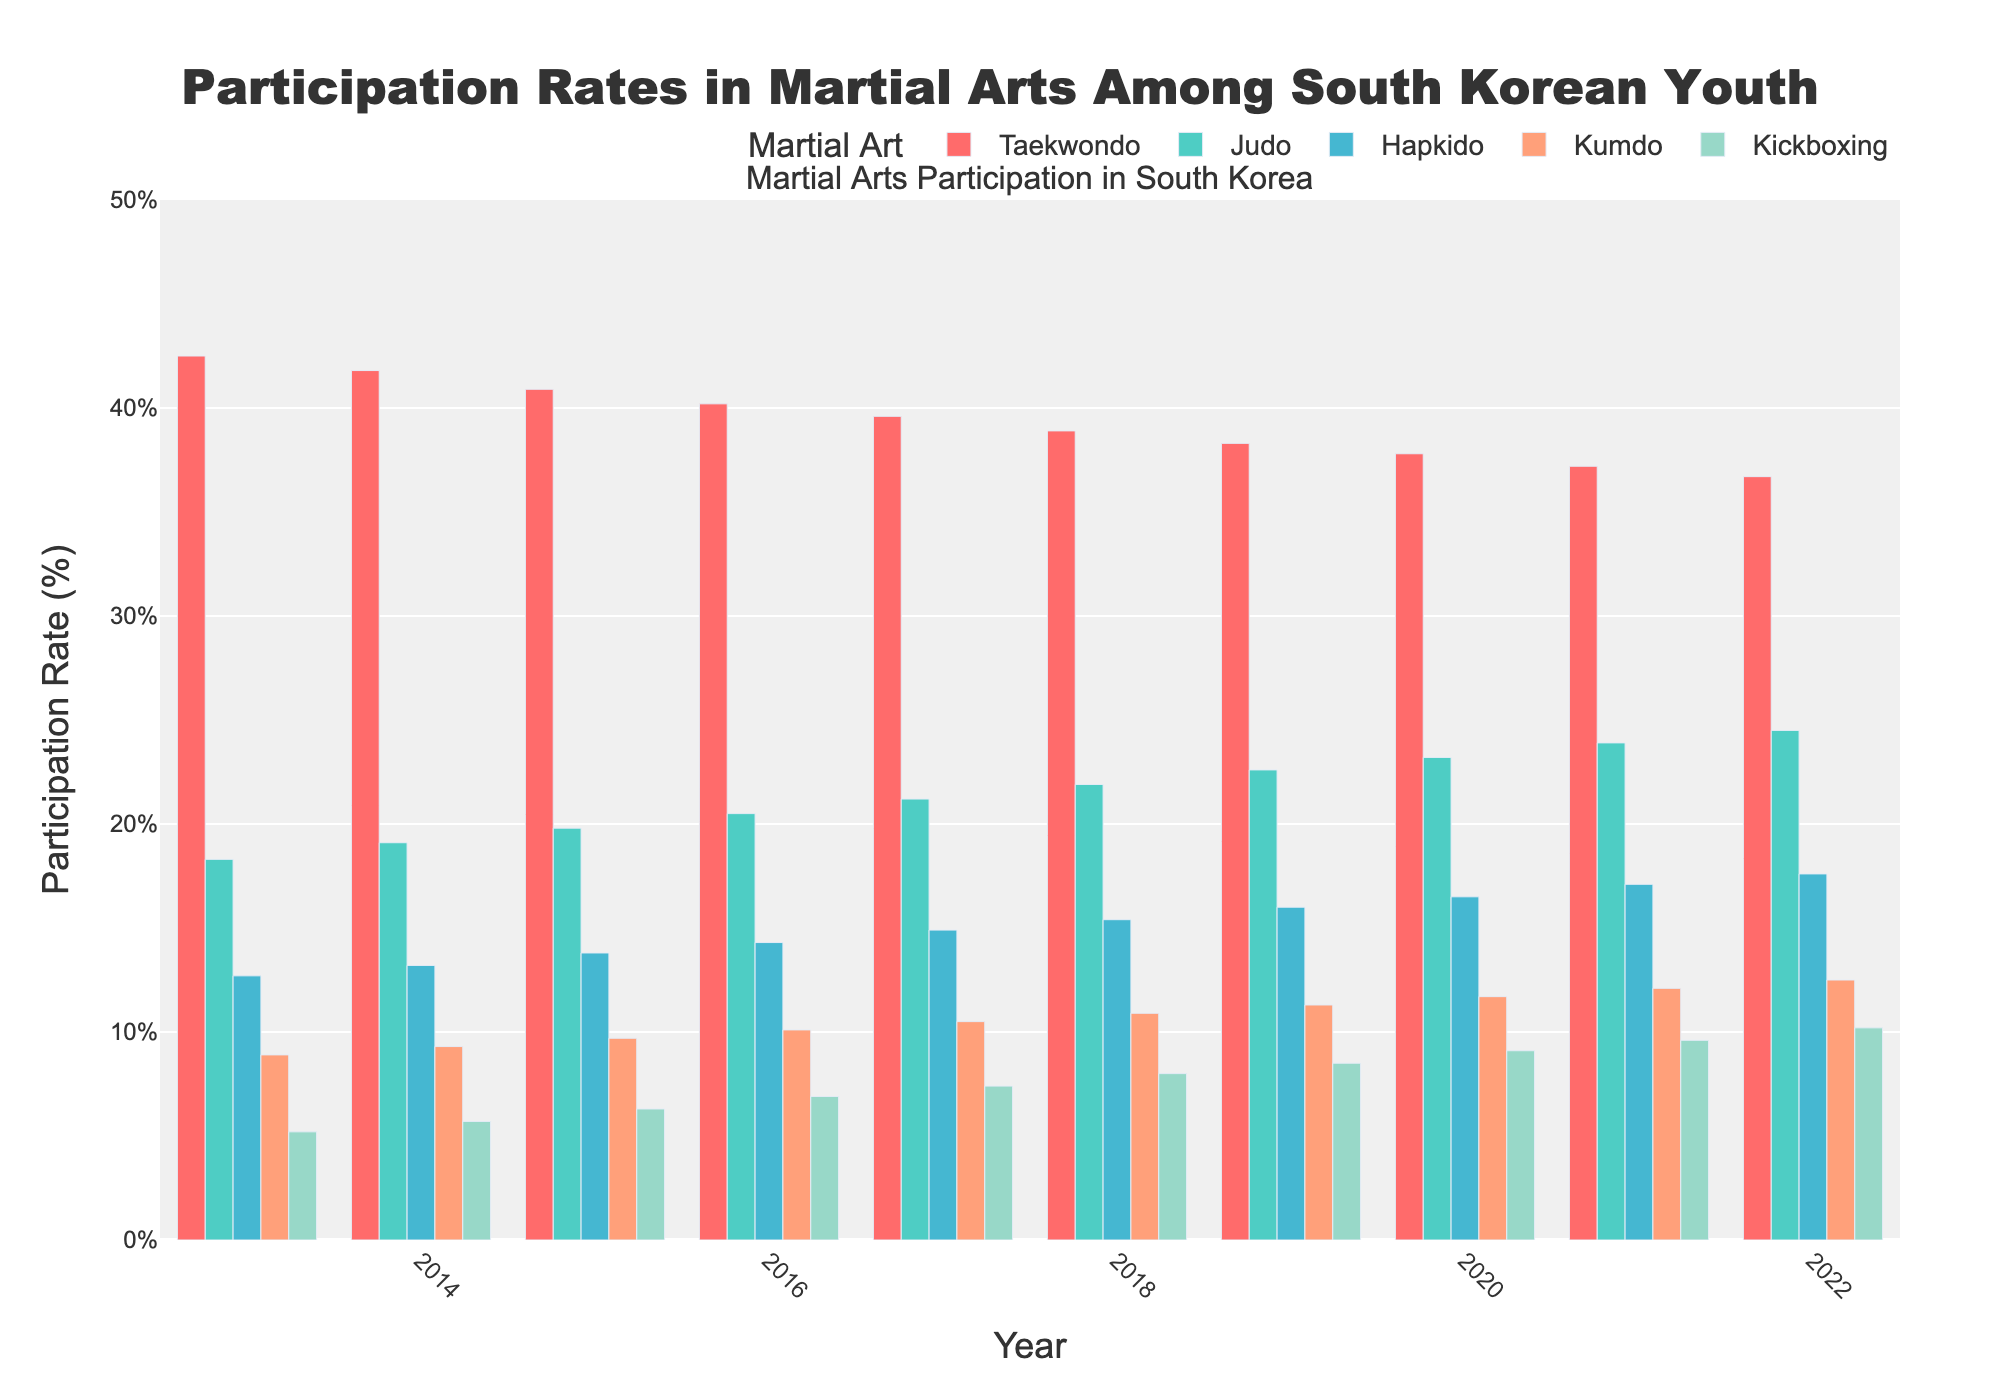What's the highest participation rate for Taekwondo in the last decade? The highest participation rate for Taekwondo can be observed by looking at the tallest red bar in the chart. The tallest red bar corresponds to the year 2013 with a participation rate of 42.5%.
Answer: 42.5% By how much did the participation rate of Kickboxing increase from 2013 to 2022? To find this, subtract the participation rate of Kickboxing in 2013 (5.2%) from the rate in 2022 (10.2%). The increase is 10.2% - 5.2% = 5%.
Answer: 5% Which year had the highest combined participation rate of Judo and Hapkido? Add the participation rates of Judo and Hapkido for each year and identify the year with the highest sum. For 2022, Judo has 24.5% and Hapkido has 17.6%, leading to a combined rate of 42.1%. This is the highest combined rate among all years.
Answer: 2022 Which martial art had the most consistent participation rate over the decade? The most consistent participation rate can be identified by observing the martial art with the least fluctuation in the height of its bars. Taekwondo shows the least amount of change in bar height over the decade, suggesting it has the most consistent rate.
Answer: Taekwondo What is the average participation rate of Kumdo over the decade? To calculate the average, sum the participation rates of Kumdo for all the years and divide by the total number of years. (8.9 + 9.3 + 9.7 + 10.1 + 10.5 + 10.9 + 11.3 + 11.7 + 12.1 + 12.5) / 10 = 10.7%.
Answer: 10.7% In which year did Hapkido see the largest increase in participation rate compared to the previous year? To find this, compute the year-over-year increase for Hapkido and identify the maximum. The largest increase is between 2013 (12.7%) and 2014 (13.2%), which is 0.5%.
Answer: 2014 Which martial art had the lowest participation rate in 2015? The lowest participation rate can be found by looking for the shortest bar in each group of bars for 2015. In this year, Kickboxing has the shortest bar with a rate of 6.3%.
Answer: Kickboxing 